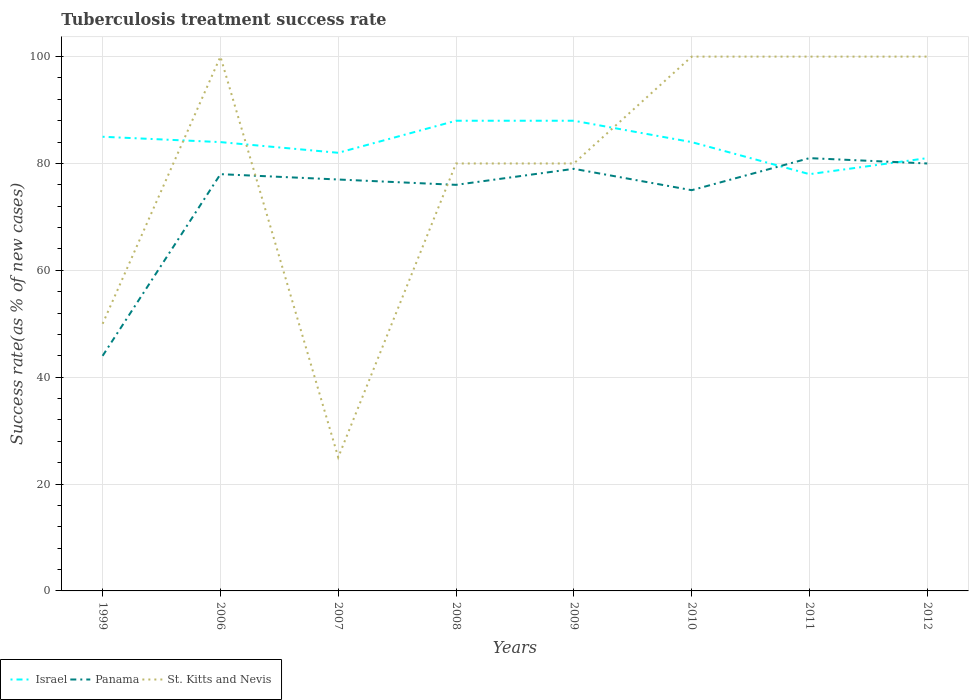How many different coloured lines are there?
Your answer should be very brief. 3. Does the line corresponding to Panama intersect with the line corresponding to Israel?
Offer a terse response. Yes. In which year was the tuberculosis treatment success rate in St. Kitts and Nevis maximum?
Ensure brevity in your answer.  2007. What is the difference between the highest and the lowest tuberculosis treatment success rate in Israel?
Make the answer very short. 5. Is the tuberculosis treatment success rate in Israel strictly greater than the tuberculosis treatment success rate in St. Kitts and Nevis over the years?
Provide a short and direct response. No. What is the difference between two consecutive major ticks on the Y-axis?
Keep it short and to the point. 20. Does the graph contain grids?
Ensure brevity in your answer.  Yes. How many legend labels are there?
Give a very brief answer. 3. What is the title of the graph?
Make the answer very short. Tuberculosis treatment success rate. Does "Bolivia" appear as one of the legend labels in the graph?
Your answer should be compact. No. What is the label or title of the Y-axis?
Offer a terse response. Success rate(as % of new cases). What is the Success rate(as % of new cases) in Panama in 1999?
Your response must be concise. 44. What is the Success rate(as % of new cases) in St. Kitts and Nevis in 1999?
Ensure brevity in your answer.  50. What is the Success rate(as % of new cases) of Panama in 2007?
Provide a succinct answer. 77. What is the Success rate(as % of new cases) in St. Kitts and Nevis in 2007?
Ensure brevity in your answer.  25. What is the Success rate(as % of new cases) in Israel in 2008?
Your answer should be very brief. 88. What is the Success rate(as % of new cases) of Panama in 2008?
Ensure brevity in your answer.  76. What is the Success rate(as % of new cases) of Israel in 2009?
Provide a succinct answer. 88. What is the Success rate(as % of new cases) of Panama in 2009?
Your answer should be very brief. 79. What is the Success rate(as % of new cases) in St. Kitts and Nevis in 2010?
Offer a terse response. 100. What is the Success rate(as % of new cases) in Panama in 2011?
Ensure brevity in your answer.  81. What is the Success rate(as % of new cases) of St. Kitts and Nevis in 2011?
Offer a terse response. 100. What is the Success rate(as % of new cases) of Israel in 2012?
Provide a short and direct response. 81. What is the Success rate(as % of new cases) in St. Kitts and Nevis in 2012?
Make the answer very short. 100. Across all years, what is the maximum Success rate(as % of new cases) in Israel?
Your answer should be compact. 88. Across all years, what is the minimum Success rate(as % of new cases) of Israel?
Give a very brief answer. 78. Across all years, what is the minimum Success rate(as % of new cases) in Panama?
Make the answer very short. 44. Across all years, what is the minimum Success rate(as % of new cases) of St. Kitts and Nevis?
Ensure brevity in your answer.  25. What is the total Success rate(as % of new cases) of Israel in the graph?
Offer a very short reply. 670. What is the total Success rate(as % of new cases) in Panama in the graph?
Give a very brief answer. 590. What is the total Success rate(as % of new cases) in St. Kitts and Nevis in the graph?
Provide a short and direct response. 635. What is the difference between the Success rate(as % of new cases) in Panama in 1999 and that in 2006?
Keep it short and to the point. -34. What is the difference between the Success rate(as % of new cases) in St. Kitts and Nevis in 1999 and that in 2006?
Provide a short and direct response. -50. What is the difference between the Success rate(as % of new cases) in Israel in 1999 and that in 2007?
Your answer should be compact. 3. What is the difference between the Success rate(as % of new cases) of Panama in 1999 and that in 2007?
Offer a terse response. -33. What is the difference between the Success rate(as % of new cases) in St. Kitts and Nevis in 1999 and that in 2007?
Make the answer very short. 25. What is the difference between the Success rate(as % of new cases) in Panama in 1999 and that in 2008?
Keep it short and to the point. -32. What is the difference between the Success rate(as % of new cases) in St. Kitts and Nevis in 1999 and that in 2008?
Your answer should be very brief. -30. What is the difference between the Success rate(as % of new cases) in Israel in 1999 and that in 2009?
Make the answer very short. -3. What is the difference between the Success rate(as % of new cases) in Panama in 1999 and that in 2009?
Keep it short and to the point. -35. What is the difference between the Success rate(as % of new cases) of Israel in 1999 and that in 2010?
Offer a terse response. 1. What is the difference between the Success rate(as % of new cases) in Panama in 1999 and that in 2010?
Make the answer very short. -31. What is the difference between the Success rate(as % of new cases) of St. Kitts and Nevis in 1999 and that in 2010?
Offer a very short reply. -50. What is the difference between the Success rate(as % of new cases) of Israel in 1999 and that in 2011?
Make the answer very short. 7. What is the difference between the Success rate(as % of new cases) in Panama in 1999 and that in 2011?
Ensure brevity in your answer.  -37. What is the difference between the Success rate(as % of new cases) in St. Kitts and Nevis in 1999 and that in 2011?
Provide a short and direct response. -50. What is the difference between the Success rate(as % of new cases) in Israel in 1999 and that in 2012?
Keep it short and to the point. 4. What is the difference between the Success rate(as % of new cases) of Panama in 1999 and that in 2012?
Give a very brief answer. -36. What is the difference between the Success rate(as % of new cases) in Israel in 2006 and that in 2007?
Provide a succinct answer. 2. What is the difference between the Success rate(as % of new cases) in Panama in 2006 and that in 2007?
Your response must be concise. 1. What is the difference between the Success rate(as % of new cases) in St. Kitts and Nevis in 2006 and that in 2007?
Keep it short and to the point. 75. What is the difference between the Success rate(as % of new cases) of Israel in 2006 and that in 2008?
Give a very brief answer. -4. What is the difference between the Success rate(as % of new cases) of St. Kitts and Nevis in 2006 and that in 2008?
Ensure brevity in your answer.  20. What is the difference between the Success rate(as % of new cases) in Panama in 2006 and that in 2009?
Give a very brief answer. -1. What is the difference between the Success rate(as % of new cases) in St. Kitts and Nevis in 2006 and that in 2009?
Offer a terse response. 20. What is the difference between the Success rate(as % of new cases) in Panama in 2006 and that in 2010?
Offer a terse response. 3. What is the difference between the Success rate(as % of new cases) of St. Kitts and Nevis in 2006 and that in 2010?
Offer a very short reply. 0. What is the difference between the Success rate(as % of new cases) in Panama in 2006 and that in 2011?
Give a very brief answer. -3. What is the difference between the Success rate(as % of new cases) of St. Kitts and Nevis in 2006 and that in 2011?
Ensure brevity in your answer.  0. What is the difference between the Success rate(as % of new cases) of Israel in 2006 and that in 2012?
Your answer should be compact. 3. What is the difference between the Success rate(as % of new cases) of St. Kitts and Nevis in 2006 and that in 2012?
Your answer should be very brief. 0. What is the difference between the Success rate(as % of new cases) of Israel in 2007 and that in 2008?
Provide a succinct answer. -6. What is the difference between the Success rate(as % of new cases) in St. Kitts and Nevis in 2007 and that in 2008?
Offer a terse response. -55. What is the difference between the Success rate(as % of new cases) of Israel in 2007 and that in 2009?
Provide a succinct answer. -6. What is the difference between the Success rate(as % of new cases) in St. Kitts and Nevis in 2007 and that in 2009?
Keep it short and to the point. -55. What is the difference between the Success rate(as % of new cases) in Israel in 2007 and that in 2010?
Your answer should be very brief. -2. What is the difference between the Success rate(as % of new cases) in St. Kitts and Nevis in 2007 and that in 2010?
Offer a very short reply. -75. What is the difference between the Success rate(as % of new cases) in Israel in 2007 and that in 2011?
Make the answer very short. 4. What is the difference between the Success rate(as % of new cases) of St. Kitts and Nevis in 2007 and that in 2011?
Offer a terse response. -75. What is the difference between the Success rate(as % of new cases) of St. Kitts and Nevis in 2007 and that in 2012?
Your answer should be compact. -75. What is the difference between the Success rate(as % of new cases) of Panama in 2008 and that in 2009?
Offer a very short reply. -3. What is the difference between the Success rate(as % of new cases) in Israel in 2008 and that in 2011?
Provide a succinct answer. 10. What is the difference between the Success rate(as % of new cases) of Israel in 2008 and that in 2012?
Provide a succinct answer. 7. What is the difference between the Success rate(as % of new cases) of Panama in 2008 and that in 2012?
Your answer should be compact. -4. What is the difference between the Success rate(as % of new cases) in St. Kitts and Nevis in 2008 and that in 2012?
Keep it short and to the point. -20. What is the difference between the Success rate(as % of new cases) of Panama in 2009 and that in 2010?
Your answer should be very brief. 4. What is the difference between the Success rate(as % of new cases) of Panama in 2009 and that in 2012?
Provide a succinct answer. -1. What is the difference between the Success rate(as % of new cases) in St. Kitts and Nevis in 2009 and that in 2012?
Your answer should be compact. -20. What is the difference between the Success rate(as % of new cases) in Israel in 2010 and that in 2011?
Provide a succinct answer. 6. What is the difference between the Success rate(as % of new cases) of Panama in 2010 and that in 2011?
Your answer should be very brief. -6. What is the difference between the Success rate(as % of new cases) in Panama in 2010 and that in 2012?
Ensure brevity in your answer.  -5. What is the difference between the Success rate(as % of new cases) of Israel in 2011 and that in 2012?
Offer a terse response. -3. What is the difference between the Success rate(as % of new cases) in Panama in 2011 and that in 2012?
Make the answer very short. 1. What is the difference between the Success rate(as % of new cases) in Israel in 1999 and the Success rate(as % of new cases) in Panama in 2006?
Your response must be concise. 7. What is the difference between the Success rate(as % of new cases) in Israel in 1999 and the Success rate(as % of new cases) in St. Kitts and Nevis in 2006?
Your answer should be very brief. -15. What is the difference between the Success rate(as % of new cases) of Panama in 1999 and the Success rate(as % of new cases) of St. Kitts and Nevis in 2006?
Your answer should be very brief. -56. What is the difference between the Success rate(as % of new cases) in Israel in 1999 and the Success rate(as % of new cases) in St. Kitts and Nevis in 2007?
Keep it short and to the point. 60. What is the difference between the Success rate(as % of new cases) in Israel in 1999 and the Success rate(as % of new cases) in Panama in 2008?
Ensure brevity in your answer.  9. What is the difference between the Success rate(as % of new cases) of Panama in 1999 and the Success rate(as % of new cases) of St. Kitts and Nevis in 2008?
Your answer should be compact. -36. What is the difference between the Success rate(as % of new cases) in Panama in 1999 and the Success rate(as % of new cases) in St. Kitts and Nevis in 2009?
Offer a very short reply. -36. What is the difference between the Success rate(as % of new cases) in Israel in 1999 and the Success rate(as % of new cases) in St. Kitts and Nevis in 2010?
Make the answer very short. -15. What is the difference between the Success rate(as % of new cases) in Panama in 1999 and the Success rate(as % of new cases) in St. Kitts and Nevis in 2010?
Offer a terse response. -56. What is the difference between the Success rate(as % of new cases) of Israel in 1999 and the Success rate(as % of new cases) of Panama in 2011?
Provide a short and direct response. 4. What is the difference between the Success rate(as % of new cases) in Panama in 1999 and the Success rate(as % of new cases) in St. Kitts and Nevis in 2011?
Give a very brief answer. -56. What is the difference between the Success rate(as % of new cases) of Israel in 1999 and the Success rate(as % of new cases) of Panama in 2012?
Provide a short and direct response. 5. What is the difference between the Success rate(as % of new cases) in Israel in 1999 and the Success rate(as % of new cases) in St. Kitts and Nevis in 2012?
Offer a very short reply. -15. What is the difference between the Success rate(as % of new cases) in Panama in 1999 and the Success rate(as % of new cases) in St. Kitts and Nevis in 2012?
Make the answer very short. -56. What is the difference between the Success rate(as % of new cases) of Israel in 2006 and the Success rate(as % of new cases) of Panama in 2008?
Provide a short and direct response. 8. What is the difference between the Success rate(as % of new cases) of Israel in 2006 and the Success rate(as % of new cases) of St. Kitts and Nevis in 2008?
Provide a succinct answer. 4. What is the difference between the Success rate(as % of new cases) of Panama in 2006 and the Success rate(as % of new cases) of St. Kitts and Nevis in 2008?
Offer a very short reply. -2. What is the difference between the Success rate(as % of new cases) in Israel in 2006 and the Success rate(as % of new cases) in St. Kitts and Nevis in 2009?
Make the answer very short. 4. What is the difference between the Success rate(as % of new cases) in Panama in 2006 and the Success rate(as % of new cases) in St. Kitts and Nevis in 2009?
Your answer should be very brief. -2. What is the difference between the Success rate(as % of new cases) in Israel in 2006 and the Success rate(as % of new cases) in Panama in 2011?
Offer a terse response. 3. What is the difference between the Success rate(as % of new cases) in Panama in 2006 and the Success rate(as % of new cases) in St. Kitts and Nevis in 2011?
Provide a short and direct response. -22. What is the difference between the Success rate(as % of new cases) of Israel in 2006 and the Success rate(as % of new cases) of St. Kitts and Nevis in 2012?
Offer a very short reply. -16. What is the difference between the Success rate(as % of new cases) of Panama in 2007 and the Success rate(as % of new cases) of St. Kitts and Nevis in 2008?
Your answer should be very brief. -3. What is the difference between the Success rate(as % of new cases) of Israel in 2007 and the Success rate(as % of new cases) of Panama in 2010?
Offer a terse response. 7. What is the difference between the Success rate(as % of new cases) of Israel in 2007 and the Success rate(as % of new cases) of St. Kitts and Nevis in 2010?
Provide a short and direct response. -18. What is the difference between the Success rate(as % of new cases) of Panama in 2007 and the Success rate(as % of new cases) of St. Kitts and Nevis in 2010?
Make the answer very short. -23. What is the difference between the Success rate(as % of new cases) of Israel in 2007 and the Success rate(as % of new cases) of Panama in 2011?
Offer a very short reply. 1. What is the difference between the Success rate(as % of new cases) of Israel in 2007 and the Success rate(as % of new cases) of St. Kitts and Nevis in 2011?
Provide a succinct answer. -18. What is the difference between the Success rate(as % of new cases) in Panama in 2007 and the Success rate(as % of new cases) in St. Kitts and Nevis in 2011?
Offer a very short reply. -23. What is the difference between the Success rate(as % of new cases) in Israel in 2007 and the Success rate(as % of new cases) in Panama in 2012?
Make the answer very short. 2. What is the difference between the Success rate(as % of new cases) of Panama in 2007 and the Success rate(as % of new cases) of St. Kitts and Nevis in 2012?
Offer a very short reply. -23. What is the difference between the Success rate(as % of new cases) of Israel in 2008 and the Success rate(as % of new cases) of Panama in 2009?
Make the answer very short. 9. What is the difference between the Success rate(as % of new cases) of Israel in 2008 and the Success rate(as % of new cases) of St. Kitts and Nevis in 2009?
Your response must be concise. 8. What is the difference between the Success rate(as % of new cases) of Israel in 2008 and the Success rate(as % of new cases) of Panama in 2011?
Give a very brief answer. 7. What is the difference between the Success rate(as % of new cases) in Israel in 2008 and the Success rate(as % of new cases) in St. Kitts and Nevis in 2011?
Give a very brief answer. -12. What is the difference between the Success rate(as % of new cases) of Panama in 2008 and the Success rate(as % of new cases) of St. Kitts and Nevis in 2011?
Give a very brief answer. -24. What is the difference between the Success rate(as % of new cases) of Israel in 2008 and the Success rate(as % of new cases) of St. Kitts and Nevis in 2012?
Make the answer very short. -12. What is the difference between the Success rate(as % of new cases) in Panama in 2008 and the Success rate(as % of new cases) in St. Kitts and Nevis in 2012?
Offer a terse response. -24. What is the difference between the Success rate(as % of new cases) in Israel in 2009 and the Success rate(as % of new cases) in Panama in 2011?
Ensure brevity in your answer.  7. What is the difference between the Success rate(as % of new cases) of Israel in 2009 and the Success rate(as % of new cases) of Panama in 2012?
Your answer should be very brief. 8. What is the difference between the Success rate(as % of new cases) of Israel in 2009 and the Success rate(as % of new cases) of St. Kitts and Nevis in 2012?
Keep it short and to the point. -12. What is the difference between the Success rate(as % of new cases) of Israel in 2010 and the Success rate(as % of new cases) of Panama in 2011?
Make the answer very short. 3. What is the difference between the Success rate(as % of new cases) of Panama in 2010 and the Success rate(as % of new cases) of St. Kitts and Nevis in 2011?
Ensure brevity in your answer.  -25. What is the difference between the Success rate(as % of new cases) in Israel in 2010 and the Success rate(as % of new cases) in Panama in 2012?
Provide a succinct answer. 4. What is the difference between the Success rate(as % of new cases) in Panama in 2011 and the Success rate(as % of new cases) in St. Kitts and Nevis in 2012?
Your answer should be compact. -19. What is the average Success rate(as % of new cases) in Israel per year?
Provide a short and direct response. 83.75. What is the average Success rate(as % of new cases) in Panama per year?
Provide a succinct answer. 73.75. What is the average Success rate(as % of new cases) of St. Kitts and Nevis per year?
Give a very brief answer. 79.38. In the year 1999, what is the difference between the Success rate(as % of new cases) of Israel and Success rate(as % of new cases) of St. Kitts and Nevis?
Your response must be concise. 35. In the year 1999, what is the difference between the Success rate(as % of new cases) of Panama and Success rate(as % of new cases) of St. Kitts and Nevis?
Provide a short and direct response. -6. In the year 2006, what is the difference between the Success rate(as % of new cases) of Israel and Success rate(as % of new cases) of St. Kitts and Nevis?
Provide a short and direct response. -16. In the year 2007, what is the difference between the Success rate(as % of new cases) of Israel and Success rate(as % of new cases) of Panama?
Make the answer very short. 5. In the year 2007, what is the difference between the Success rate(as % of new cases) of Panama and Success rate(as % of new cases) of St. Kitts and Nevis?
Ensure brevity in your answer.  52. In the year 2008, what is the difference between the Success rate(as % of new cases) of Israel and Success rate(as % of new cases) of Panama?
Provide a short and direct response. 12. In the year 2008, what is the difference between the Success rate(as % of new cases) in Israel and Success rate(as % of new cases) in St. Kitts and Nevis?
Provide a succinct answer. 8. In the year 2009, what is the difference between the Success rate(as % of new cases) of Panama and Success rate(as % of new cases) of St. Kitts and Nevis?
Your answer should be compact. -1. In the year 2010, what is the difference between the Success rate(as % of new cases) of Panama and Success rate(as % of new cases) of St. Kitts and Nevis?
Offer a very short reply. -25. In the year 2011, what is the difference between the Success rate(as % of new cases) of Israel and Success rate(as % of new cases) of St. Kitts and Nevis?
Give a very brief answer. -22. In the year 2011, what is the difference between the Success rate(as % of new cases) of Panama and Success rate(as % of new cases) of St. Kitts and Nevis?
Make the answer very short. -19. In the year 2012, what is the difference between the Success rate(as % of new cases) in Israel and Success rate(as % of new cases) in Panama?
Your response must be concise. 1. In the year 2012, what is the difference between the Success rate(as % of new cases) of Panama and Success rate(as % of new cases) of St. Kitts and Nevis?
Your response must be concise. -20. What is the ratio of the Success rate(as % of new cases) of Israel in 1999 to that in 2006?
Offer a terse response. 1.01. What is the ratio of the Success rate(as % of new cases) of Panama in 1999 to that in 2006?
Your answer should be compact. 0.56. What is the ratio of the Success rate(as % of new cases) in Israel in 1999 to that in 2007?
Provide a succinct answer. 1.04. What is the ratio of the Success rate(as % of new cases) in Panama in 1999 to that in 2007?
Your response must be concise. 0.57. What is the ratio of the Success rate(as % of new cases) in Israel in 1999 to that in 2008?
Provide a short and direct response. 0.97. What is the ratio of the Success rate(as % of new cases) in Panama in 1999 to that in 2008?
Offer a terse response. 0.58. What is the ratio of the Success rate(as % of new cases) of Israel in 1999 to that in 2009?
Provide a succinct answer. 0.97. What is the ratio of the Success rate(as % of new cases) in Panama in 1999 to that in 2009?
Your response must be concise. 0.56. What is the ratio of the Success rate(as % of new cases) of Israel in 1999 to that in 2010?
Your answer should be compact. 1.01. What is the ratio of the Success rate(as % of new cases) of Panama in 1999 to that in 2010?
Ensure brevity in your answer.  0.59. What is the ratio of the Success rate(as % of new cases) in St. Kitts and Nevis in 1999 to that in 2010?
Provide a short and direct response. 0.5. What is the ratio of the Success rate(as % of new cases) in Israel in 1999 to that in 2011?
Provide a succinct answer. 1.09. What is the ratio of the Success rate(as % of new cases) of Panama in 1999 to that in 2011?
Provide a succinct answer. 0.54. What is the ratio of the Success rate(as % of new cases) of St. Kitts and Nevis in 1999 to that in 2011?
Your answer should be compact. 0.5. What is the ratio of the Success rate(as % of new cases) in Israel in 1999 to that in 2012?
Make the answer very short. 1.05. What is the ratio of the Success rate(as % of new cases) of Panama in 1999 to that in 2012?
Your answer should be compact. 0.55. What is the ratio of the Success rate(as % of new cases) in Israel in 2006 to that in 2007?
Make the answer very short. 1.02. What is the ratio of the Success rate(as % of new cases) of Panama in 2006 to that in 2007?
Keep it short and to the point. 1.01. What is the ratio of the Success rate(as % of new cases) of St. Kitts and Nevis in 2006 to that in 2007?
Ensure brevity in your answer.  4. What is the ratio of the Success rate(as % of new cases) of Israel in 2006 to that in 2008?
Keep it short and to the point. 0.95. What is the ratio of the Success rate(as % of new cases) of Panama in 2006 to that in 2008?
Offer a very short reply. 1.03. What is the ratio of the Success rate(as % of new cases) of Israel in 2006 to that in 2009?
Make the answer very short. 0.95. What is the ratio of the Success rate(as % of new cases) in Panama in 2006 to that in 2009?
Provide a short and direct response. 0.99. What is the ratio of the Success rate(as % of new cases) of Israel in 2006 to that in 2010?
Provide a short and direct response. 1. What is the ratio of the Success rate(as % of new cases) in Panama in 2006 to that in 2011?
Provide a succinct answer. 0.96. What is the ratio of the Success rate(as % of new cases) of St. Kitts and Nevis in 2006 to that in 2011?
Provide a short and direct response. 1. What is the ratio of the Success rate(as % of new cases) of Panama in 2006 to that in 2012?
Keep it short and to the point. 0.97. What is the ratio of the Success rate(as % of new cases) of Israel in 2007 to that in 2008?
Offer a very short reply. 0.93. What is the ratio of the Success rate(as % of new cases) in Panama in 2007 to that in 2008?
Provide a succinct answer. 1.01. What is the ratio of the Success rate(as % of new cases) of St. Kitts and Nevis in 2007 to that in 2008?
Give a very brief answer. 0.31. What is the ratio of the Success rate(as % of new cases) in Israel in 2007 to that in 2009?
Provide a short and direct response. 0.93. What is the ratio of the Success rate(as % of new cases) in Panama in 2007 to that in 2009?
Offer a very short reply. 0.97. What is the ratio of the Success rate(as % of new cases) in St. Kitts and Nevis in 2007 to that in 2009?
Offer a very short reply. 0.31. What is the ratio of the Success rate(as % of new cases) in Israel in 2007 to that in 2010?
Ensure brevity in your answer.  0.98. What is the ratio of the Success rate(as % of new cases) in Panama in 2007 to that in 2010?
Ensure brevity in your answer.  1.03. What is the ratio of the Success rate(as % of new cases) in Israel in 2007 to that in 2011?
Ensure brevity in your answer.  1.05. What is the ratio of the Success rate(as % of new cases) of Panama in 2007 to that in 2011?
Your response must be concise. 0.95. What is the ratio of the Success rate(as % of new cases) of Israel in 2007 to that in 2012?
Your answer should be very brief. 1.01. What is the ratio of the Success rate(as % of new cases) of Panama in 2007 to that in 2012?
Give a very brief answer. 0.96. What is the ratio of the Success rate(as % of new cases) in Israel in 2008 to that in 2009?
Ensure brevity in your answer.  1. What is the ratio of the Success rate(as % of new cases) of St. Kitts and Nevis in 2008 to that in 2009?
Your answer should be very brief. 1. What is the ratio of the Success rate(as % of new cases) in Israel in 2008 to that in 2010?
Your answer should be very brief. 1.05. What is the ratio of the Success rate(as % of new cases) in Panama in 2008 to that in 2010?
Provide a succinct answer. 1.01. What is the ratio of the Success rate(as % of new cases) in Israel in 2008 to that in 2011?
Provide a succinct answer. 1.13. What is the ratio of the Success rate(as % of new cases) of Panama in 2008 to that in 2011?
Give a very brief answer. 0.94. What is the ratio of the Success rate(as % of new cases) in St. Kitts and Nevis in 2008 to that in 2011?
Make the answer very short. 0.8. What is the ratio of the Success rate(as % of new cases) of Israel in 2008 to that in 2012?
Offer a very short reply. 1.09. What is the ratio of the Success rate(as % of new cases) in Panama in 2008 to that in 2012?
Provide a succinct answer. 0.95. What is the ratio of the Success rate(as % of new cases) in St. Kitts and Nevis in 2008 to that in 2012?
Provide a succinct answer. 0.8. What is the ratio of the Success rate(as % of new cases) of Israel in 2009 to that in 2010?
Ensure brevity in your answer.  1.05. What is the ratio of the Success rate(as % of new cases) of Panama in 2009 to that in 2010?
Keep it short and to the point. 1.05. What is the ratio of the Success rate(as % of new cases) of Israel in 2009 to that in 2011?
Make the answer very short. 1.13. What is the ratio of the Success rate(as % of new cases) of Panama in 2009 to that in 2011?
Provide a short and direct response. 0.98. What is the ratio of the Success rate(as % of new cases) in Israel in 2009 to that in 2012?
Keep it short and to the point. 1.09. What is the ratio of the Success rate(as % of new cases) in Panama in 2009 to that in 2012?
Provide a succinct answer. 0.99. What is the ratio of the Success rate(as % of new cases) of Panama in 2010 to that in 2011?
Offer a terse response. 0.93. What is the ratio of the Success rate(as % of new cases) in St. Kitts and Nevis in 2010 to that in 2011?
Ensure brevity in your answer.  1. What is the ratio of the Success rate(as % of new cases) of St. Kitts and Nevis in 2010 to that in 2012?
Offer a very short reply. 1. What is the ratio of the Success rate(as % of new cases) of Israel in 2011 to that in 2012?
Make the answer very short. 0.96. What is the ratio of the Success rate(as % of new cases) of Panama in 2011 to that in 2012?
Offer a terse response. 1.01. What is the ratio of the Success rate(as % of new cases) in St. Kitts and Nevis in 2011 to that in 2012?
Provide a short and direct response. 1. What is the difference between the highest and the second highest Success rate(as % of new cases) of Panama?
Offer a terse response. 1. What is the difference between the highest and the lowest Success rate(as % of new cases) in Panama?
Give a very brief answer. 37. What is the difference between the highest and the lowest Success rate(as % of new cases) of St. Kitts and Nevis?
Provide a succinct answer. 75. 